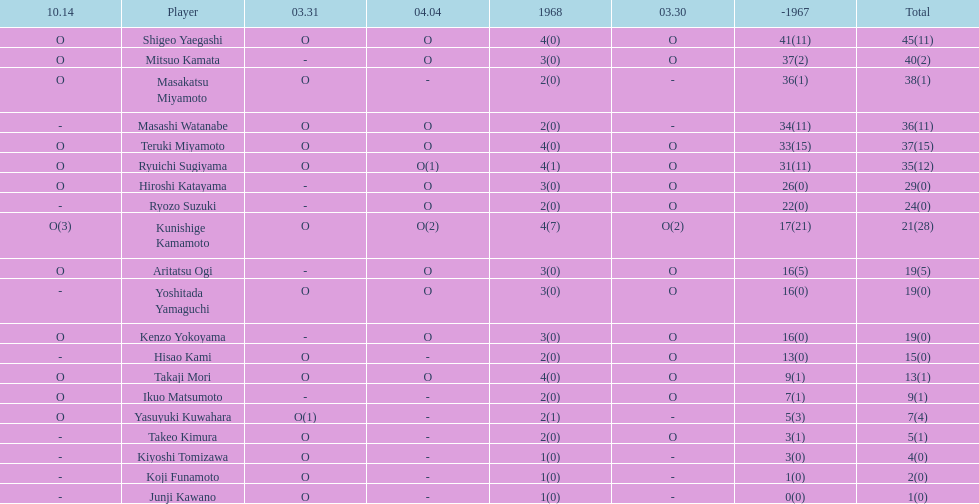Who had more points takaji mori or junji kawano? Takaji Mori. 